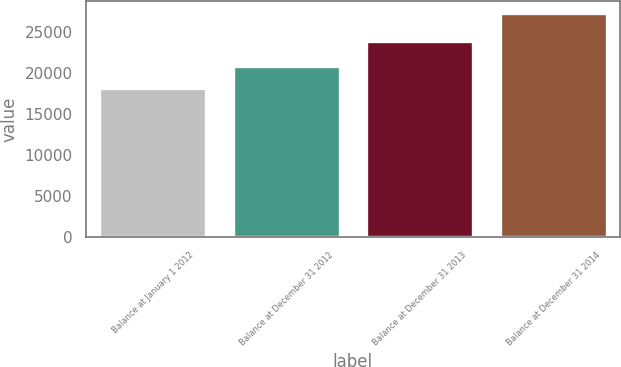Convert chart to OTSL. <chart><loc_0><loc_0><loc_500><loc_500><bar_chart><fcel>Balance at January 1 2012<fcel>Balance at December 31 2012<fcel>Balance at December 31 2013<fcel>Balance at December 31 2014<nl><fcel>18121<fcel>20884<fcel>23901<fcel>27367<nl></chart> 